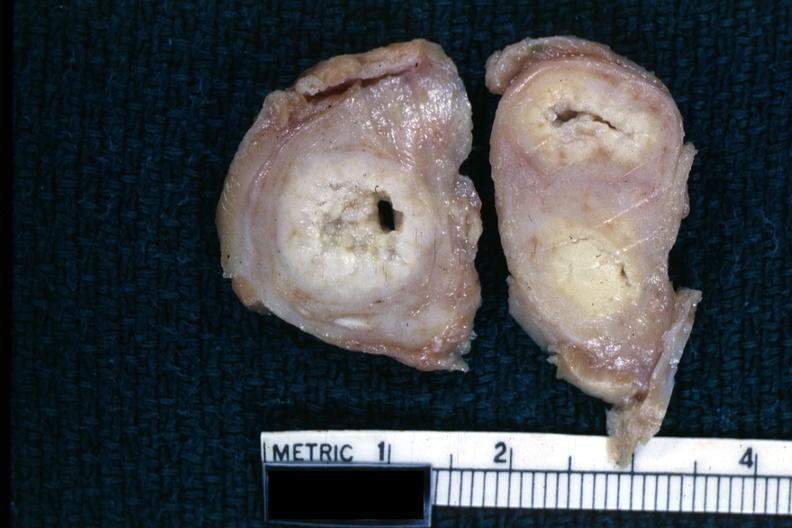what is present?
Answer the question using a single word or phrase. Fallopian tube 